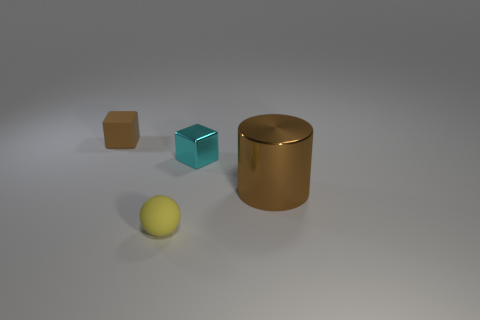Subtract all purple cylinders. Subtract all cyan balls. How many cylinders are left? 1 Add 1 big green shiny cubes. How many objects exist? 5 Subtract all spheres. How many objects are left? 3 Subtract 0 red balls. How many objects are left? 4 Subtract all small rubber things. Subtract all tiny cyan cylinders. How many objects are left? 2 Add 2 cylinders. How many cylinders are left? 3 Add 3 big shiny spheres. How many big shiny spheres exist? 3 